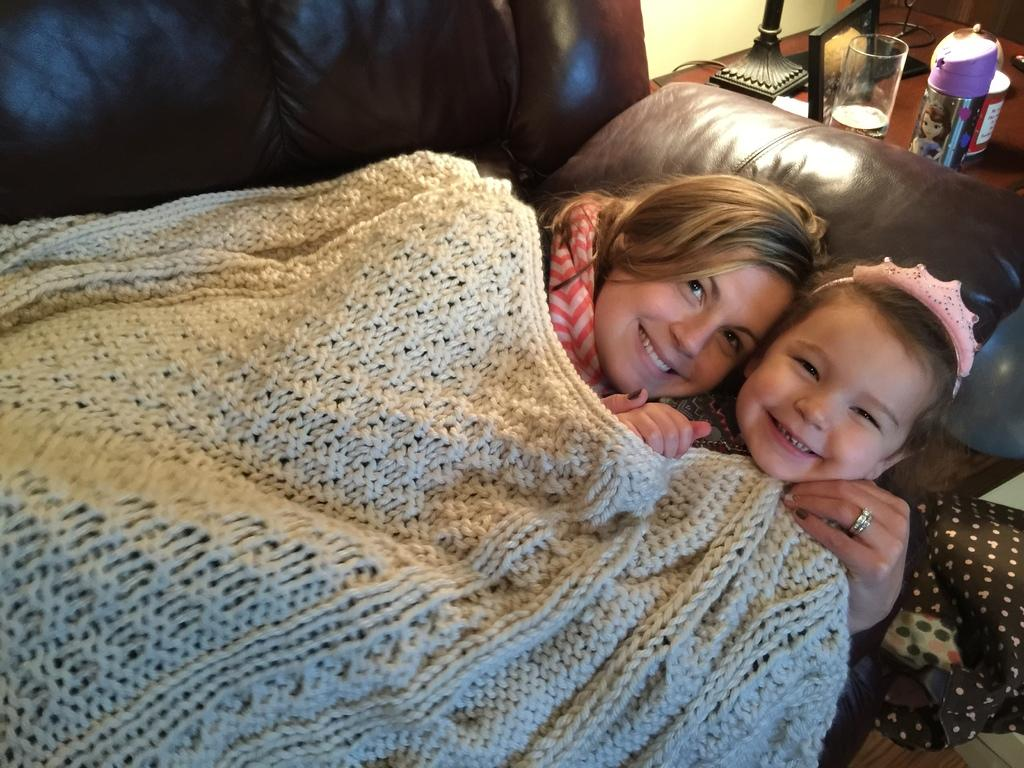Who are the people in the image? There is a lady and a girl in the image. Where are the lady and the girl located in the image? Both the lady and the girl are on a sofa. What else can be seen in the image besides the sofa? There is a table in the image. What is on the table? There are objects on the table. What are the lady and the girl wearing? The lady and the girl are wearing a woolen blanket. How many sisters are depicted in the image? The image does not show any sisters; it features a lady and a girl. What type of letters can be seen on the arm of the sofa? There are no letters visible on the arm of the sofa in the image. 